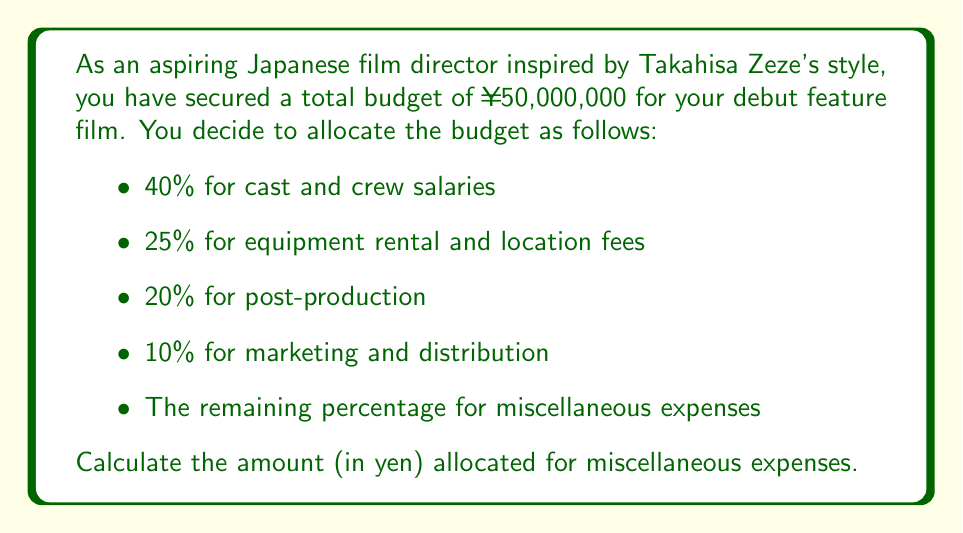Can you solve this math problem? Let's approach this step-by-step:

1) First, let's sum up the given percentages:
   $40\% + 25\% + 20\% + 10\% = 95\%$

2) This means the remaining percentage for miscellaneous expenses is:
   $100\% - 95\% = 5\%$

3) Now, we need to calculate 5% of the total budget:

   $$\text{Miscellaneous Expenses} = 5\% \times ¥50,000,000$$

4) To calculate this, we convert the percentage to a decimal:
   $5\% = 0.05$

5) Then multiply:
   $$0.05 \times ¥50,000,000 = ¥2,500,000$$

Therefore, the amount allocated for miscellaneous expenses is ¥2,500,000.
Answer: ¥2,500,000 